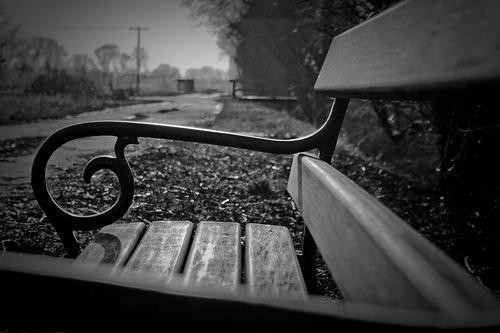How many benches are there?
Give a very brief answer. 1. 